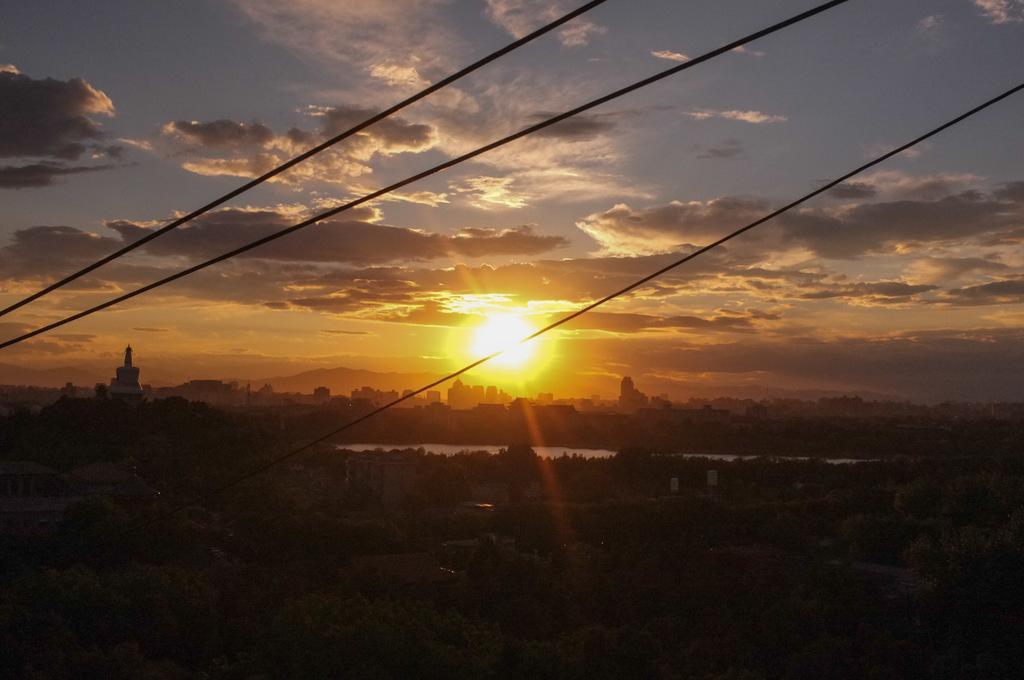In one or two sentences, can you explain what this image depicts? There are trees and buildings at the bottom of this image. We can see a sun in the middle of this image and the cloudy sky is in the background. We can see a statue on the left side of this image. 